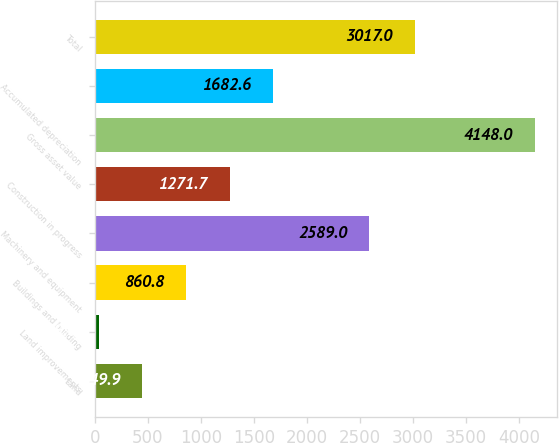Convert chart. <chart><loc_0><loc_0><loc_500><loc_500><bar_chart><fcel>Land<fcel>Land improvements<fcel>Buildings and building<fcel>Machinery and equipment<fcel>Construction in progress<fcel>Gross asset value<fcel>Accumulated depreciation<fcel>Total<nl><fcel>449.9<fcel>39<fcel>860.8<fcel>2589<fcel>1271.7<fcel>4148<fcel>1682.6<fcel>3017<nl></chart> 